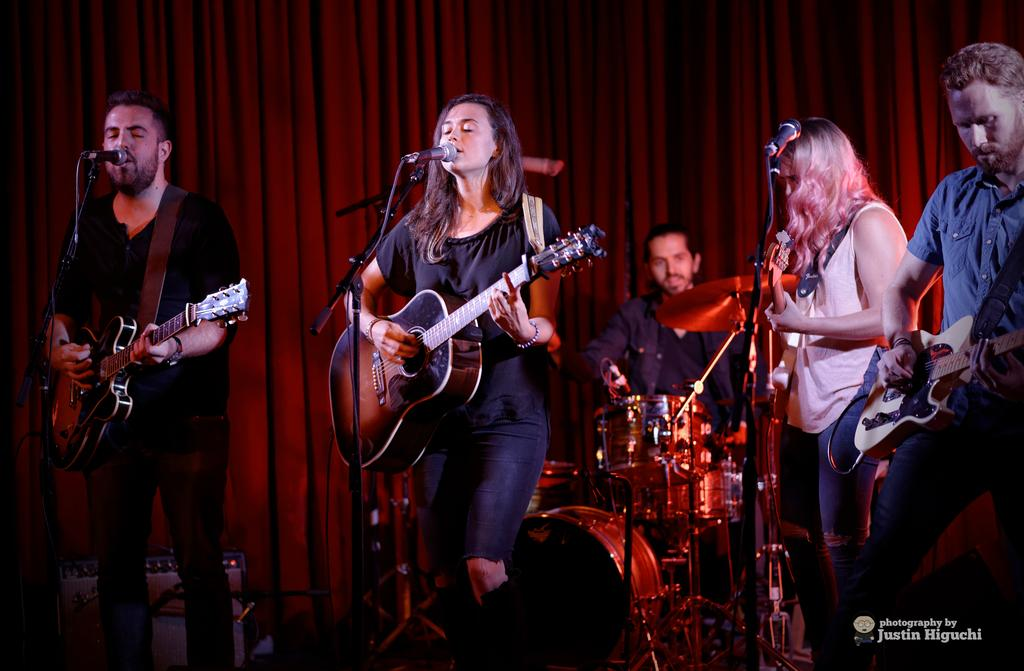How many people are performing in the image? There are five people in the image. What is the setting of the performance? The people are performing on a stage. What type of event is taking place in the image? The event is a musical event. What instruments are the people playing? The people are playing a guitar. What are the people doing while playing the guitar? The people are singing on a microphone. What type of coal is being used to fuel the performance in the image? There is no coal present in the image, and therefore it is not being used to fuel the performance. Can you describe the comfort of the tub in the image? There is no tub present in the image, so it is not possible to describe its comfort. 